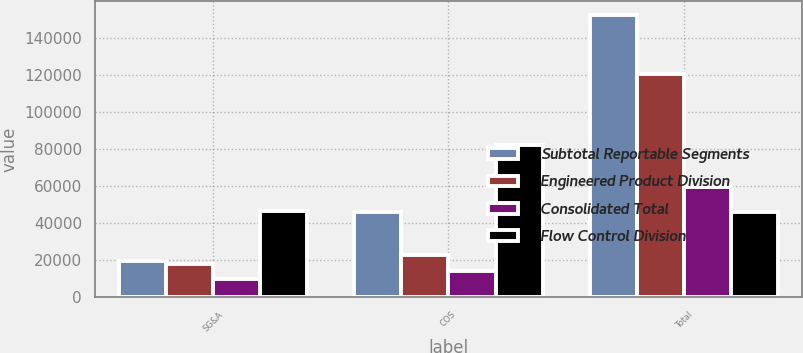Convert chart. <chart><loc_0><loc_0><loc_500><loc_500><stacked_bar_chart><ecel><fcel>SG&A<fcel>COS<fcel>Total<nl><fcel>Subtotal Reportable Segments<fcel>19390<fcel>45731<fcel>152060<nl><fcel>Engineered Product Division<fcel>17520<fcel>22753<fcel>120380<nl><fcel>Consolidated Total<fcel>9455<fcel>13718<fcel>59510<nl><fcel>Flow Control Division<fcel>46365<fcel>82202<fcel>45731<nl></chart> 